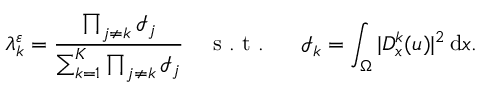<formula> <loc_0><loc_0><loc_500><loc_500>\lambda _ { k } ^ { \varepsilon } = \frac { \prod _ { j \neq k } \mathcal { I } _ { j } } { \sum _ { k = 1 } ^ { K } \prod _ { j \neq k } \mathcal { I } _ { j } } \quad s . t . \mathcal { I } _ { k } = \int _ { \Omega } | D _ { x } ^ { k } ( u ) | ^ { 2 } \, d x .</formula> 